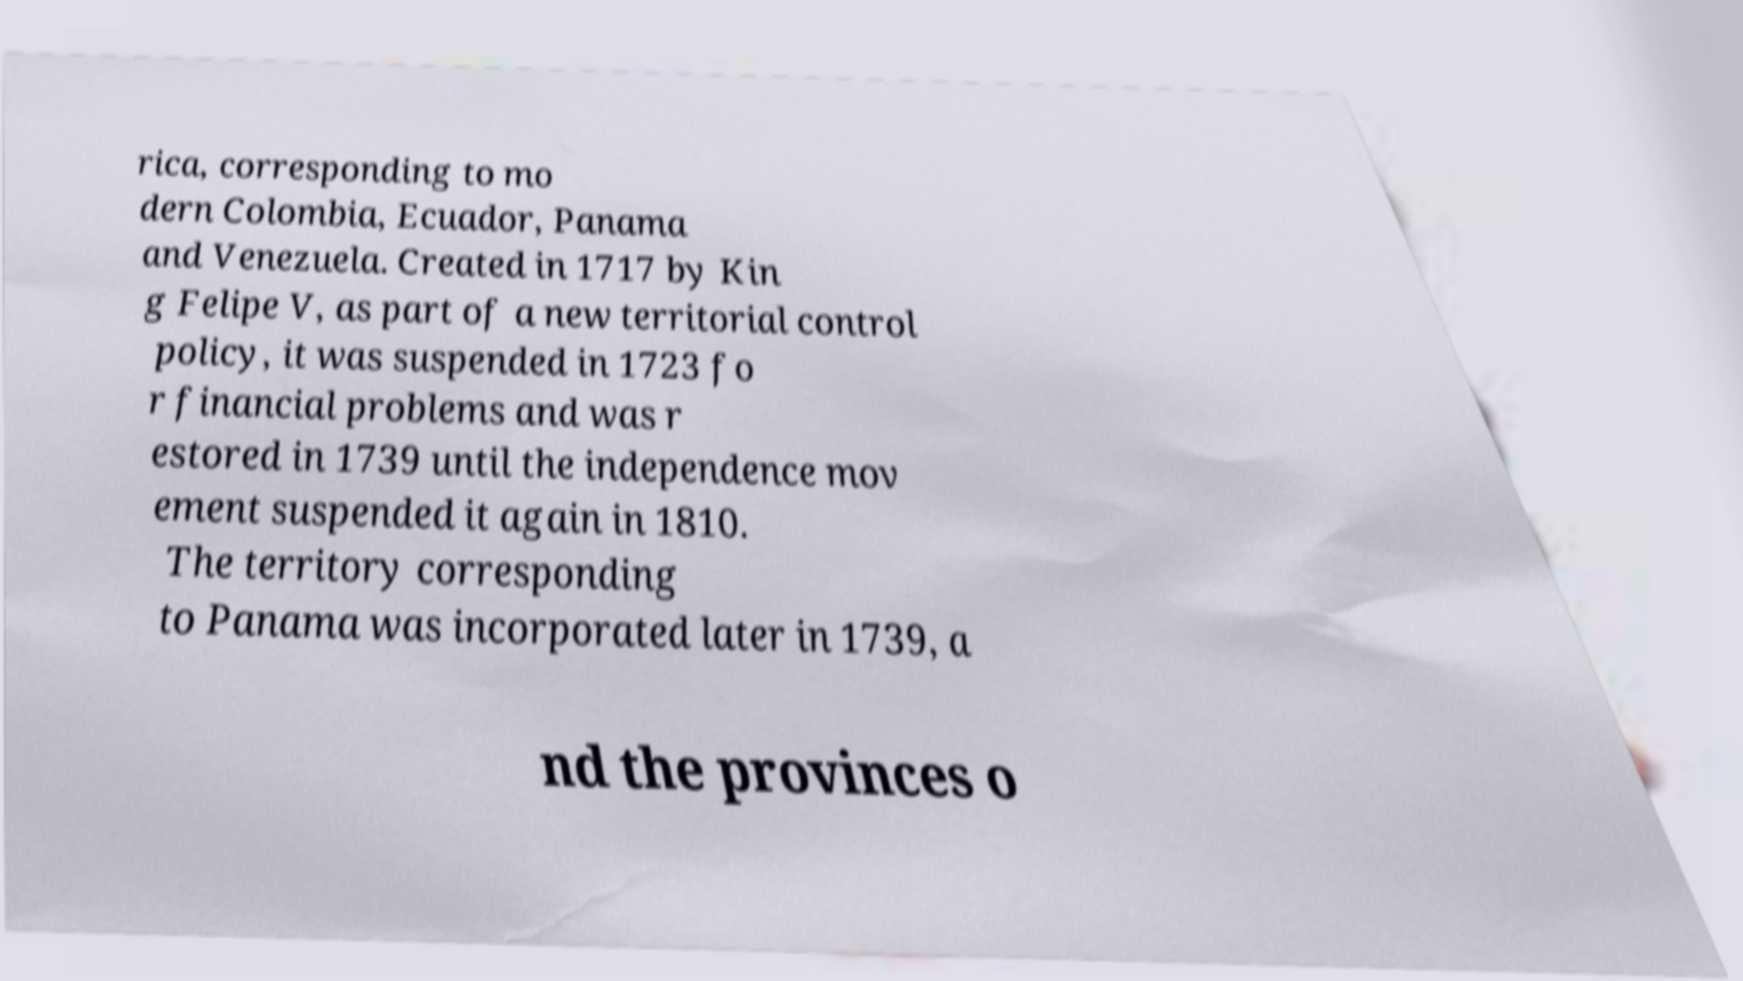Please read and relay the text visible in this image. What does it say? rica, corresponding to mo dern Colombia, Ecuador, Panama and Venezuela. Created in 1717 by Kin g Felipe V, as part of a new territorial control policy, it was suspended in 1723 fo r financial problems and was r estored in 1739 until the independence mov ement suspended it again in 1810. The territory corresponding to Panama was incorporated later in 1739, a nd the provinces o 